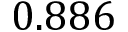<formula> <loc_0><loc_0><loc_500><loc_500>0 . 8 8 6</formula> 